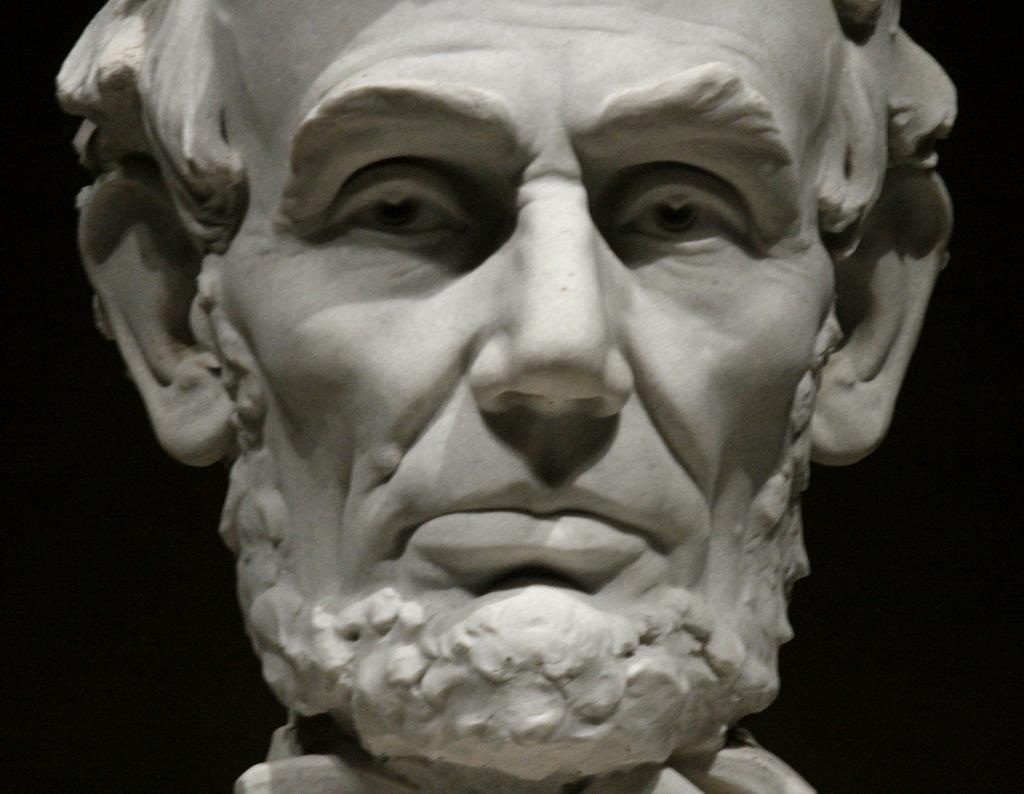In one or two sentences, can you explain what this image depicts? In this image there is a sculpture of a person truncated, the background of the image is dark. 